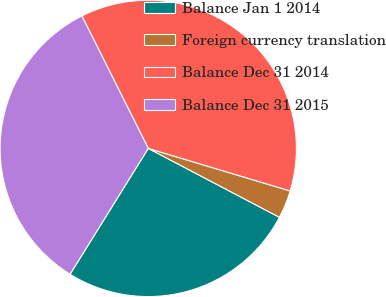<chart> <loc_0><loc_0><loc_500><loc_500><pie_chart><fcel>Balance Jan 1 2014<fcel>Foreign currency translation<fcel>Balance Dec 31 2014<fcel>Balance Dec 31 2015<nl><fcel>26.15%<fcel>3.06%<fcel>37.03%<fcel>33.75%<nl></chart> 